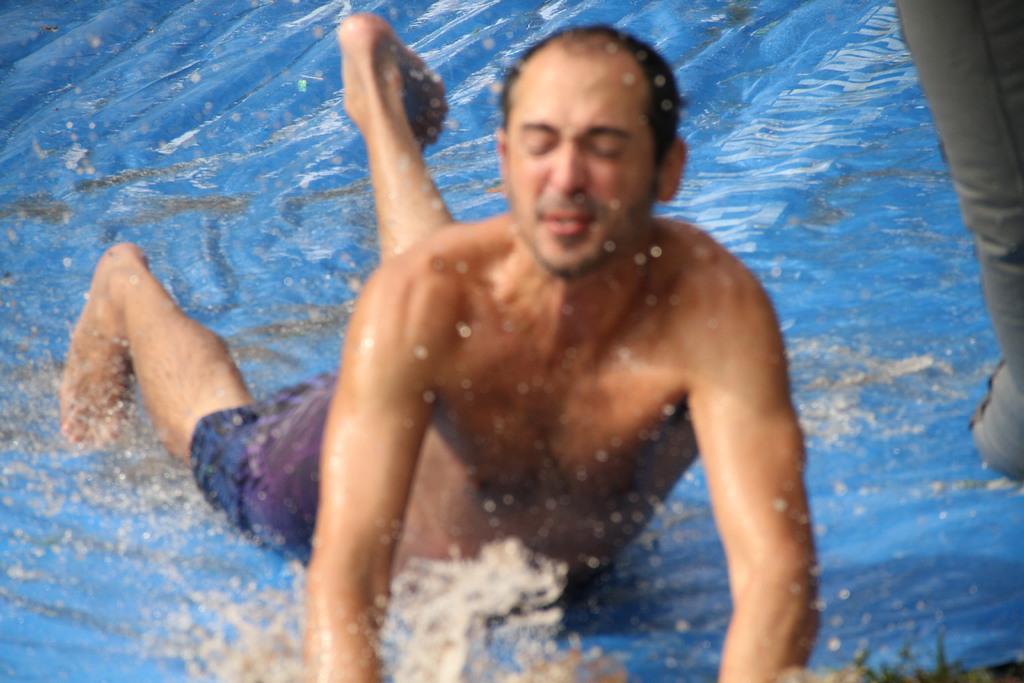Describe this image in one or two sentences. In this image we can see a man is lying on the slide and he is wearing purple color shorts. Water is present on the slide. 